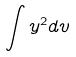<formula> <loc_0><loc_0><loc_500><loc_500>\int y ^ { 2 } d v</formula> 